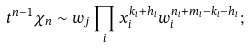<formula> <loc_0><loc_0><loc_500><loc_500>t ^ { n - 1 } \chi _ { n } \sim w _ { j } \prod _ { i } x _ { i } ^ { k _ { i } + h _ { i } } w _ { i } ^ { n _ { i } + m _ { i } - k _ { i } - h _ { i } } ;</formula> 